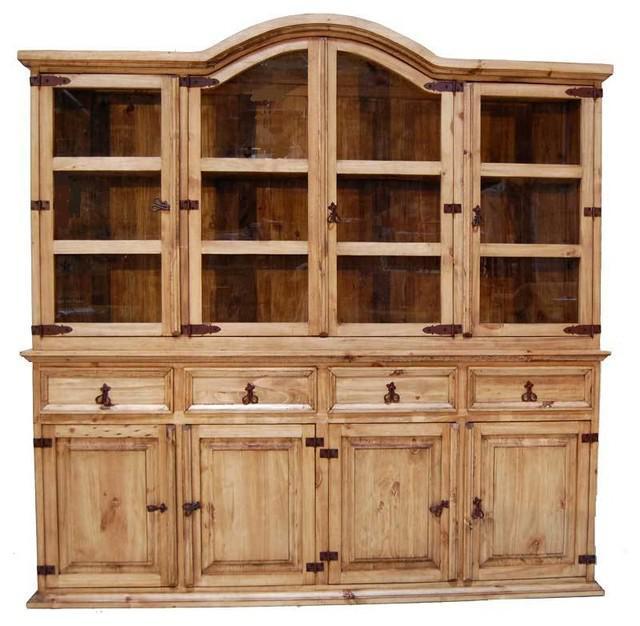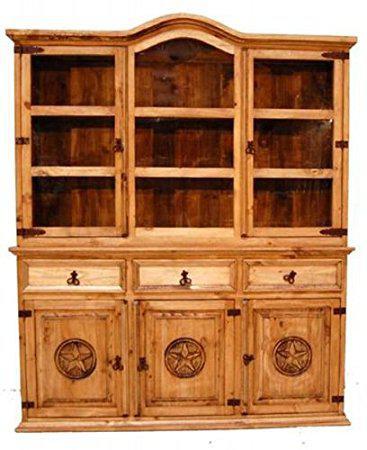The first image is the image on the left, the second image is the image on the right. Analyze the images presented: Is the assertion "Each large wooden hutch as two equal size glass doors in the upper section and two equal size solid doors in the lower section." valid? Answer yes or no. No. The first image is the image on the left, the second image is the image on the right. Examine the images to the left and right. Is the description "An image shows a two-door cabinet that is flat on top and has no visible feet." accurate? Answer yes or no. No. 